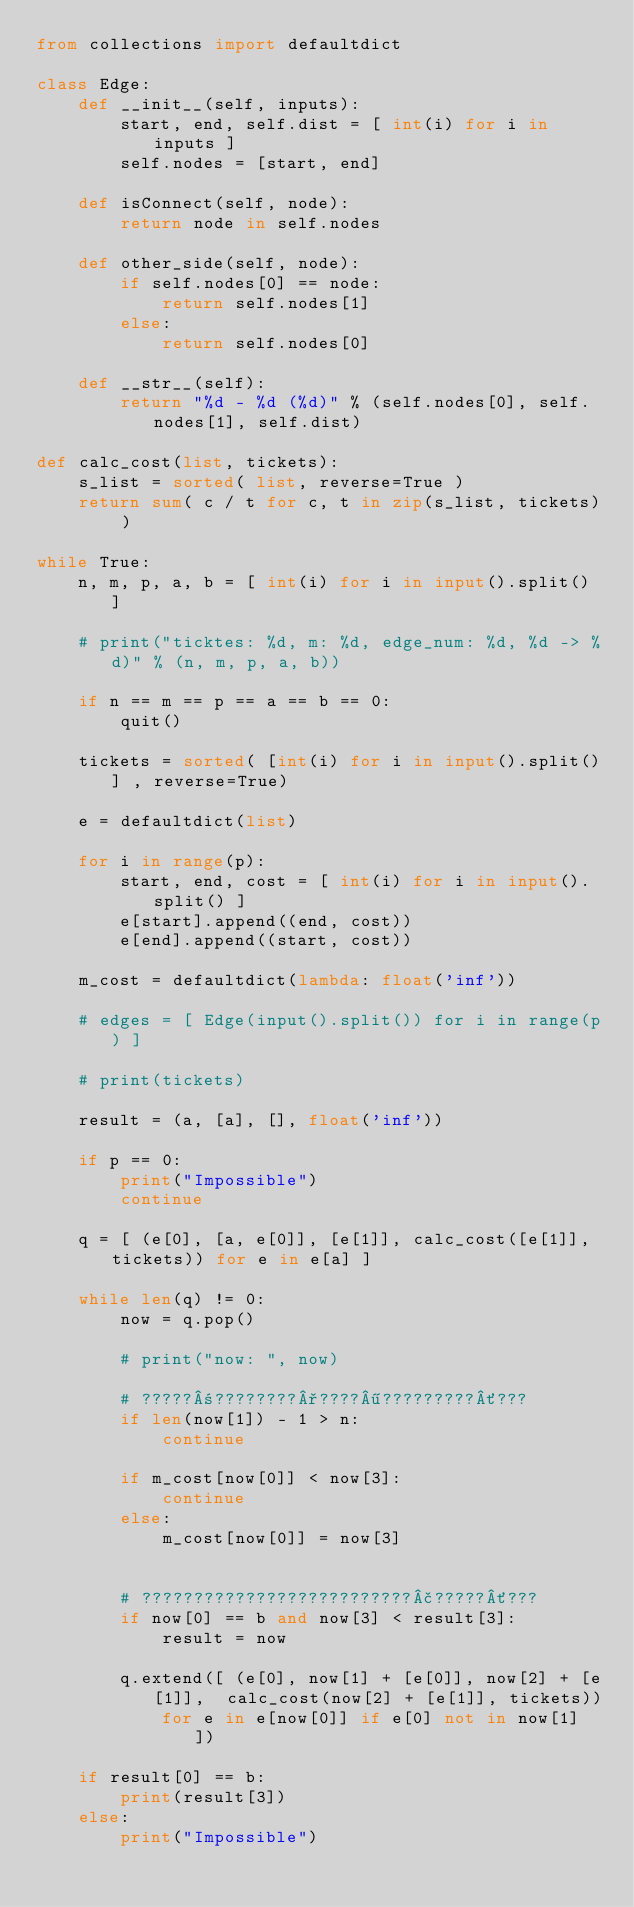Convert code to text. <code><loc_0><loc_0><loc_500><loc_500><_Python_>from collections import defaultdict

class Edge:
    def __init__(self, inputs):
        start, end, self.dist = [ int(i) for i in inputs ]
        self.nodes = [start, end]

    def isConnect(self, node):
        return node in self.nodes

    def other_side(self, node):
        if self.nodes[0] == node:
            return self.nodes[1]
        else:
            return self.nodes[0]

    def __str__(self):
        return "%d - %d (%d)" % (self.nodes[0], self.nodes[1], self.dist)

def calc_cost(list, tickets):
    s_list = sorted( list, reverse=True )
    return sum( c / t for c, t in zip(s_list, tickets) )

while True:
    n, m, p, a, b = [ int(i) for i in input().split() ]

    # print("ticktes: %d, m: %d, edge_num: %d, %d -> %d)" % (n, m, p, a, b))

    if n == m == p == a == b == 0:
        quit()

    tickets = sorted( [int(i) for i in input().split()] , reverse=True)

    e = defaultdict(list)

    for i in range(p):
        start, end, cost = [ int(i) for i in input().split() ]
        e[start].append((end, cost))
        e[end].append((start, cost))

    m_cost = defaultdict(lambda: float('inf'))

    # edges = [ Edge(input().split()) for i in range(p) ]

    # print(tickets)

    result = (a, [a], [], float('inf'))

    if p == 0:
        print("Impossible")
        continue

    q = [ (e[0], [a, e[0]], [e[1]], calc_cost([e[1]], tickets)) for e in e[a] ]

    while len(q) != 0:
        now = q.pop()

        # print("now: ", now)

        # ?????±????????°????¶?????????´???
        if len(now[1]) - 1 > n:
            continue

        if m_cost[now[0]] < now[3]:
            continue
        else:
            m_cost[now[0]] = now[3]


        # ??????????????????????????£?????´???
        if now[0] == b and now[3] < result[3]:
            result = now

        q.extend([ (e[0], now[1] + [e[0]], now[2] + [e[1]],  calc_cost(now[2] + [e[1]], tickets))
            for e in e[now[0]] if e[0] not in now[1] ])

    if result[0] == b:
        print(result[3])
    else:
        print("Impossible")</code> 